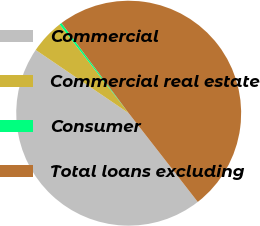<chart> <loc_0><loc_0><loc_500><loc_500><pie_chart><fcel>Commercial<fcel>Commercial real estate<fcel>Consumer<fcel>Total loans excluding<nl><fcel>45.03%<fcel>4.97%<fcel>0.33%<fcel>49.67%<nl></chart> 